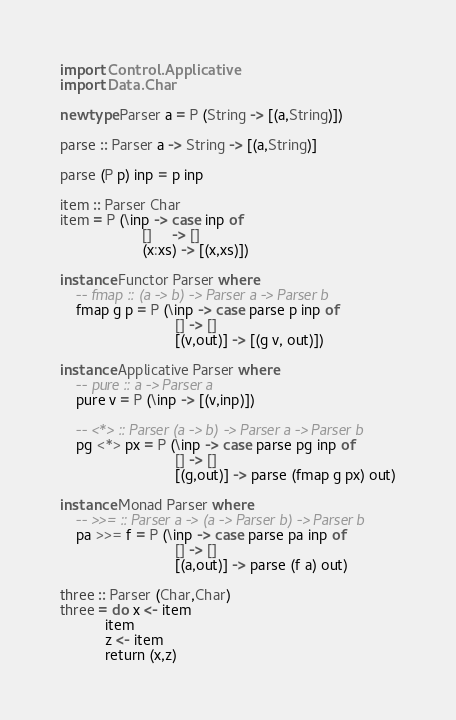Convert code to text. <code><loc_0><loc_0><loc_500><loc_500><_Haskell_>import Control.Applicative
import Data.Char

newtype Parser a = P (String -> [(a,String)])

parse :: Parser a -> String -> [(a,String)]

parse (P p) inp = p inp

item :: Parser Char
item = P (\inp -> case inp of
                    []     -> []
                    (x:xs) -> [(x,xs)])

instance Functor Parser where
    -- fmap :: (a -> b) -> Parser a -> Parser b
    fmap g p = P (\inp -> case parse p inp of
                            [] -> []
                            [(v,out)] -> [(g v, out)])

instance Applicative Parser where
    -- pure :: a -> Parser a
    pure v = P (\inp -> [(v,inp)])
    
    -- <*> :: Parser (a -> b) -> Parser a -> Parser b
    pg <*> px = P (\inp -> case parse pg inp of
                            [] -> []
                            [(g,out)] -> parse (fmap g px) out)

instance Monad Parser where
    -- >>= :: Parser a -> (a -> Parser b) -> Parser b
    pa >>= f = P (\inp -> case parse pa inp of
                            [] -> []
                            [(a,out)] -> parse (f a) out)

three :: Parser (Char,Char)
three = do x <- item
           item
           z <- item
           return (x,z)
</code> 